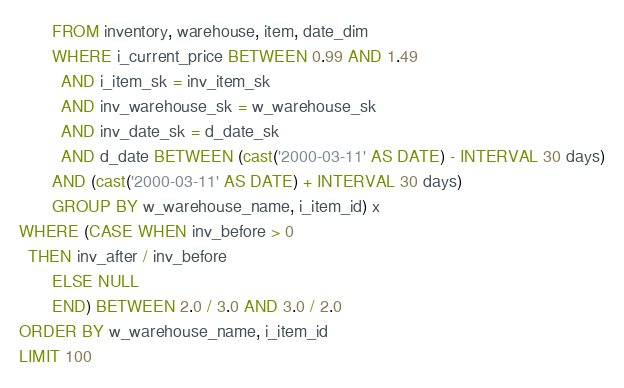Convert code to text. <code><loc_0><loc_0><loc_500><loc_500><_SQL_>       FROM inventory, warehouse, item, date_dim
       WHERE i_current_price BETWEEN 0.99 AND 1.49
         AND i_item_sk = inv_item_sk
         AND inv_warehouse_sk = w_warehouse_sk
         AND inv_date_sk = d_date_sk
         AND d_date BETWEEN (cast('2000-03-11' AS DATE) - INTERVAL 30 days)
       AND (cast('2000-03-11' AS DATE) + INTERVAL 30 days)
       GROUP BY w_warehouse_name, i_item_id) x
WHERE (CASE WHEN inv_before > 0
  THEN inv_after / inv_before
       ELSE NULL
       END) BETWEEN 2.0 / 3.0 AND 3.0 / 2.0
ORDER BY w_warehouse_name, i_item_id
LIMIT 100
</code> 